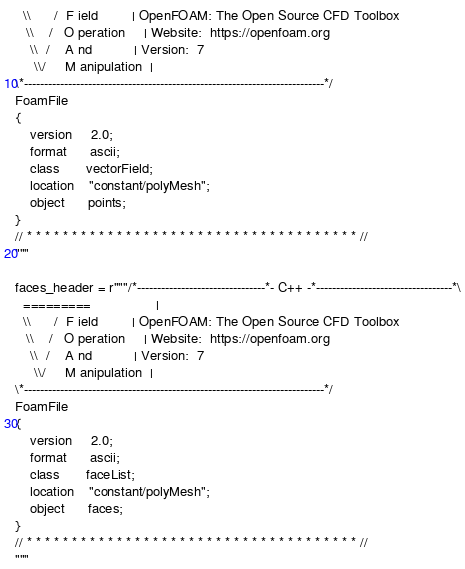<code> <loc_0><loc_0><loc_500><loc_500><_Python_>  \\      /  F ield         | OpenFOAM: The Open Source CFD Toolbox
   \\    /   O peration     | Website:  https://openfoam.org
    \\  /    A nd           | Version:  7
     \\/     M anipulation  |
\*---------------------------------------------------------------------------*/
FoamFile
{
    version     2.0;
    format      ascii;
    class       vectorField;
    location    "constant/polyMesh";
    object      points;
}
// * * * * * * * * * * * * * * * * * * * * * * * * * * * * * * * * * * * * * //
"""

faces_header = r"""/*--------------------------------*- C++ -*----------------------------------*\
  =========                 |
  \\      /  F ield         | OpenFOAM: The Open Source CFD Toolbox
   \\    /   O peration     | Website:  https://openfoam.org
    \\  /    A nd           | Version:  7
     \\/     M anipulation  |
\*---------------------------------------------------------------------------*/
FoamFile
{
    version     2.0;
    format      ascii;
    class       faceList;
    location    "constant/polyMesh";
    object      faces;
}
// * * * * * * * * * * * * * * * * * * * * * * * * * * * * * * * * * * * * * //
"""
</code> 